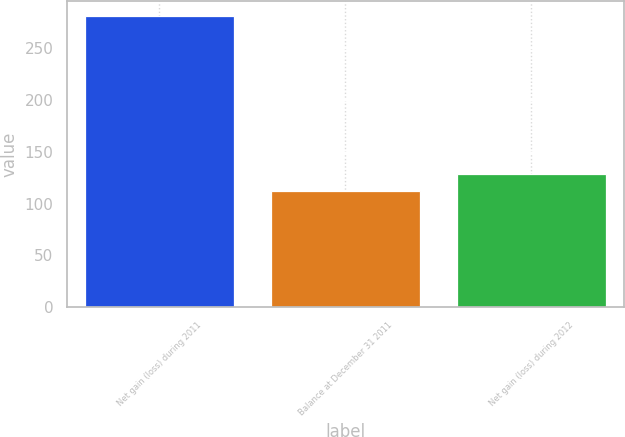Convert chart to OTSL. <chart><loc_0><loc_0><loc_500><loc_500><bar_chart><fcel>Net gain (loss) during 2011<fcel>Balance at December 31 2011<fcel>Net gain (loss) during 2012<nl><fcel>281<fcel>112<fcel>128.9<nl></chart> 